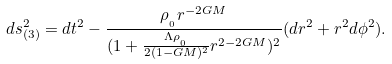<formula> <loc_0><loc_0><loc_500><loc_500>d s ^ { 2 } _ { ( 3 ) } = d t ^ { 2 } - \frac { \rho _ { _ { _ { 0 } } } r ^ { - 2 G M } } { ( 1 + \frac { \Lambda \rho _ { _ { _ { 0 } } } } { 2 ( 1 - G M ) ^ { 2 } } r ^ { 2 - 2 G M } ) ^ { 2 } } ( d r ^ { 2 } + r ^ { 2 } d \phi ^ { 2 } ) .</formula> 